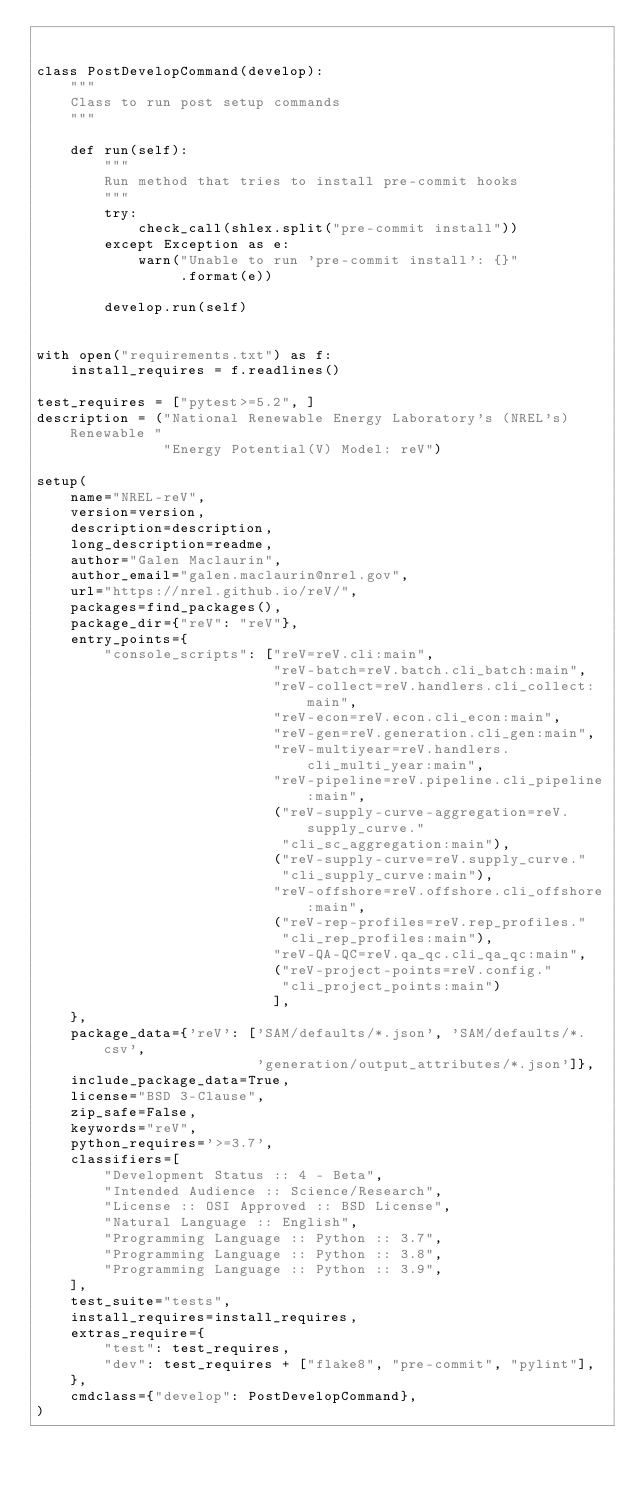<code> <loc_0><loc_0><loc_500><loc_500><_Python_>

class PostDevelopCommand(develop):
    """
    Class to run post setup commands
    """

    def run(self):
        """
        Run method that tries to install pre-commit hooks
        """
        try:
            check_call(shlex.split("pre-commit install"))
        except Exception as e:
            warn("Unable to run 'pre-commit install': {}"
                 .format(e))

        develop.run(self)


with open("requirements.txt") as f:
    install_requires = f.readlines()

test_requires = ["pytest>=5.2", ]
description = ("National Renewable Energy Laboratory's (NREL's) Renewable "
               "Energy Potential(V) Model: reV")

setup(
    name="NREL-reV",
    version=version,
    description=description,
    long_description=readme,
    author="Galen Maclaurin",
    author_email="galen.maclaurin@nrel.gov",
    url="https://nrel.github.io/reV/",
    packages=find_packages(),
    package_dir={"reV": "reV"},
    entry_points={
        "console_scripts": ["reV=reV.cli:main",
                            "reV-batch=reV.batch.cli_batch:main",
                            "reV-collect=reV.handlers.cli_collect:main",
                            "reV-econ=reV.econ.cli_econ:main",
                            "reV-gen=reV.generation.cli_gen:main",
                            "reV-multiyear=reV.handlers.cli_multi_year:main",
                            "reV-pipeline=reV.pipeline.cli_pipeline:main",
                            ("reV-supply-curve-aggregation=reV.supply_curve."
                             "cli_sc_aggregation:main"),
                            ("reV-supply-curve=reV.supply_curve."
                             "cli_supply_curve:main"),
                            "reV-offshore=reV.offshore.cli_offshore:main",
                            ("reV-rep-profiles=reV.rep_profiles."
                             "cli_rep_profiles:main"),
                            "reV-QA-QC=reV.qa_qc.cli_qa_qc:main",
                            ("reV-project-points=reV.config."
                             "cli_project_points:main")
                            ],
    },
    package_data={'reV': ['SAM/defaults/*.json', 'SAM/defaults/*.csv',
                          'generation/output_attributes/*.json']},
    include_package_data=True,
    license="BSD 3-Clause",
    zip_safe=False,
    keywords="reV",
    python_requires='>=3.7',
    classifiers=[
        "Development Status :: 4 - Beta",
        "Intended Audience :: Science/Research",
        "License :: OSI Approved :: BSD License",
        "Natural Language :: English",
        "Programming Language :: Python :: 3.7",
        "Programming Language :: Python :: 3.8",
        "Programming Language :: Python :: 3.9",
    ],
    test_suite="tests",
    install_requires=install_requires,
    extras_require={
        "test": test_requires,
        "dev": test_requires + ["flake8", "pre-commit", "pylint"],
    },
    cmdclass={"develop": PostDevelopCommand},
)
</code> 